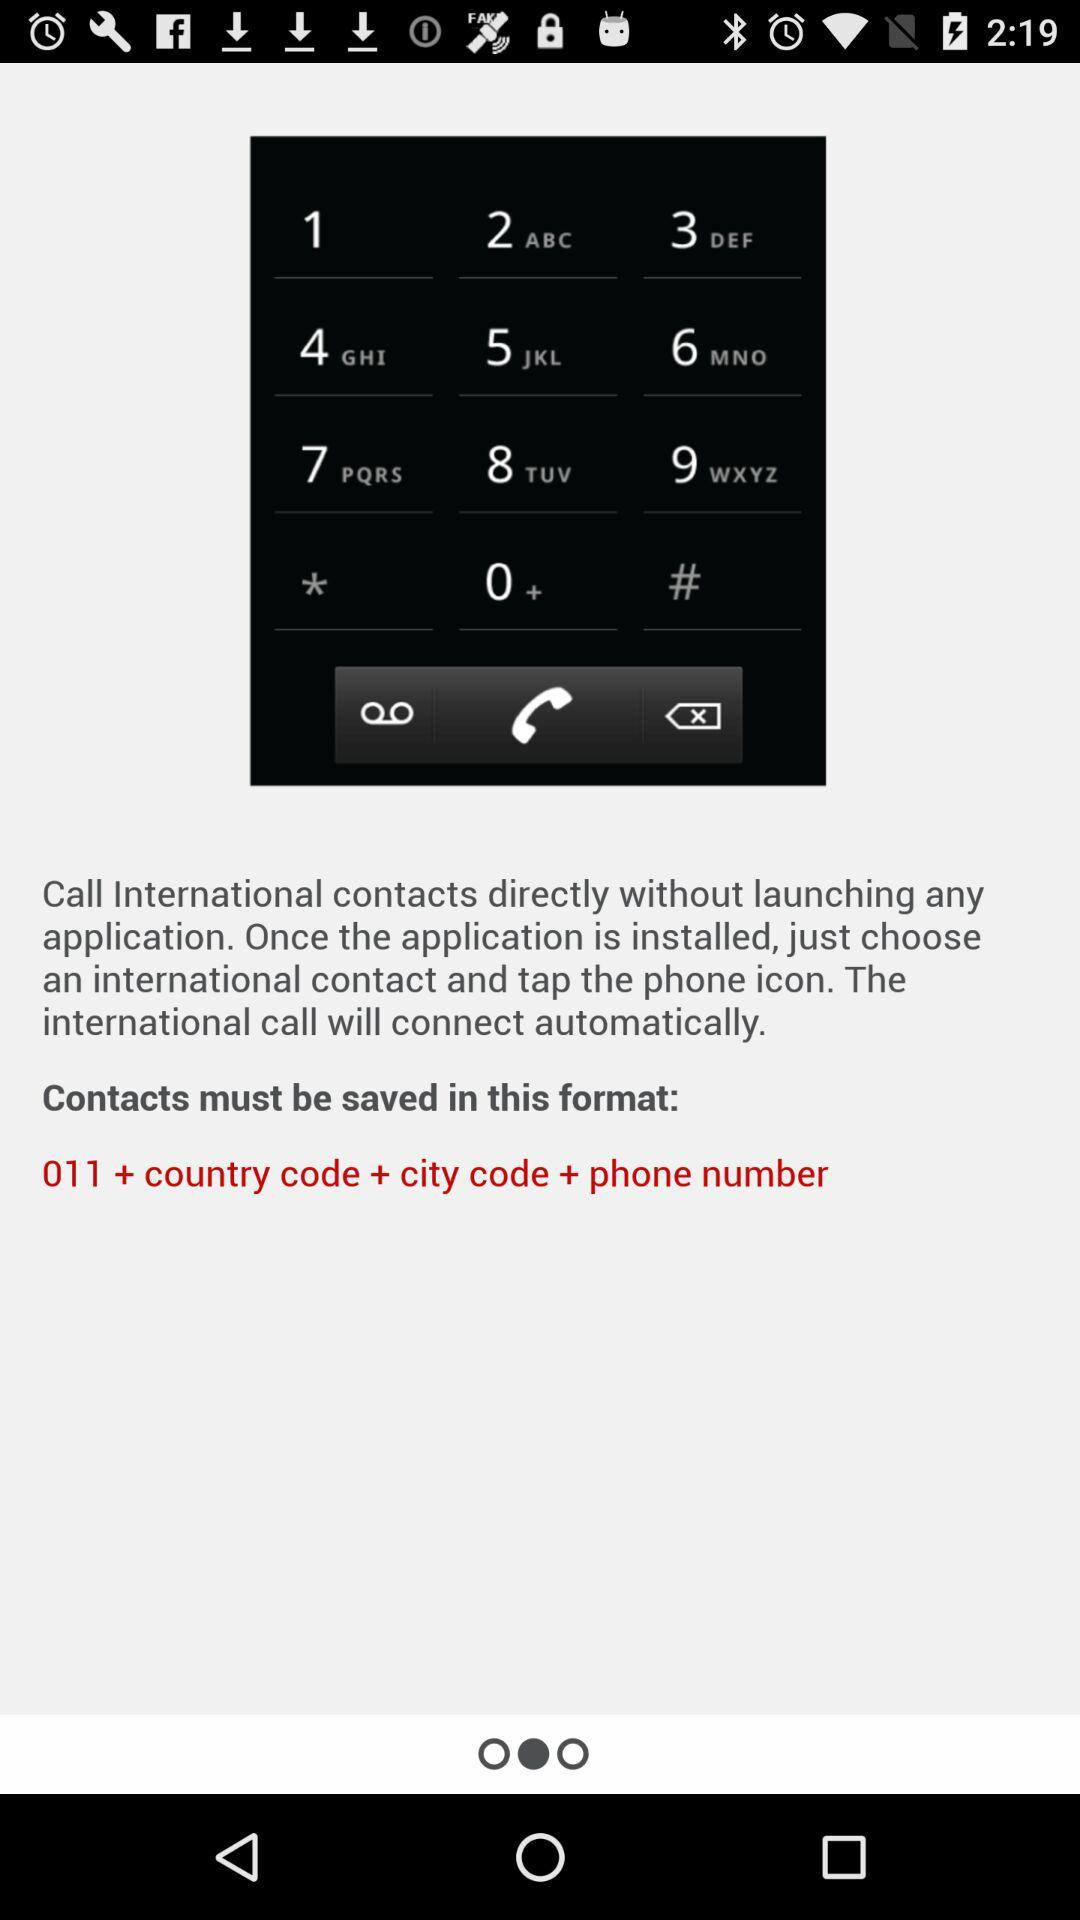How many text elements are there in the bottom half of the screen?
Answer the question using a single word or phrase. 3 